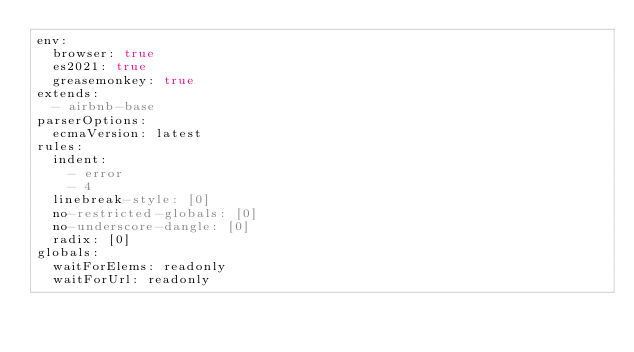<code> <loc_0><loc_0><loc_500><loc_500><_YAML_>env:
  browser: true
  es2021: true
  greasemonkey: true
extends:
  - airbnb-base
parserOptions:
  ecmaVersion: latest
rules:
  indent:
    - error
    - 4
  linebreak-style: [0]
  no-restricted-globals: [0]
  no-underscore-dangle: [0]
  radix: [0]
globals:
  waitForElems: readonly
  waitForUrl: readonly
</code> 